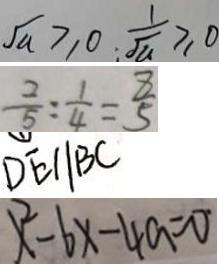<formula> <loc_0><loc_0><loc_500><loc_500>\sqrt { a } \geq 0 ; \frac { 1 } { \sqrt { a } } \geq 0 
 \frac { 2 } { 5 } : \frac { 1 } { 4 } = \frac { 8 } { 5 } 
 D E / / B C 
 x ^ { 2 } - 6 x - 4 a = 0</formula> 